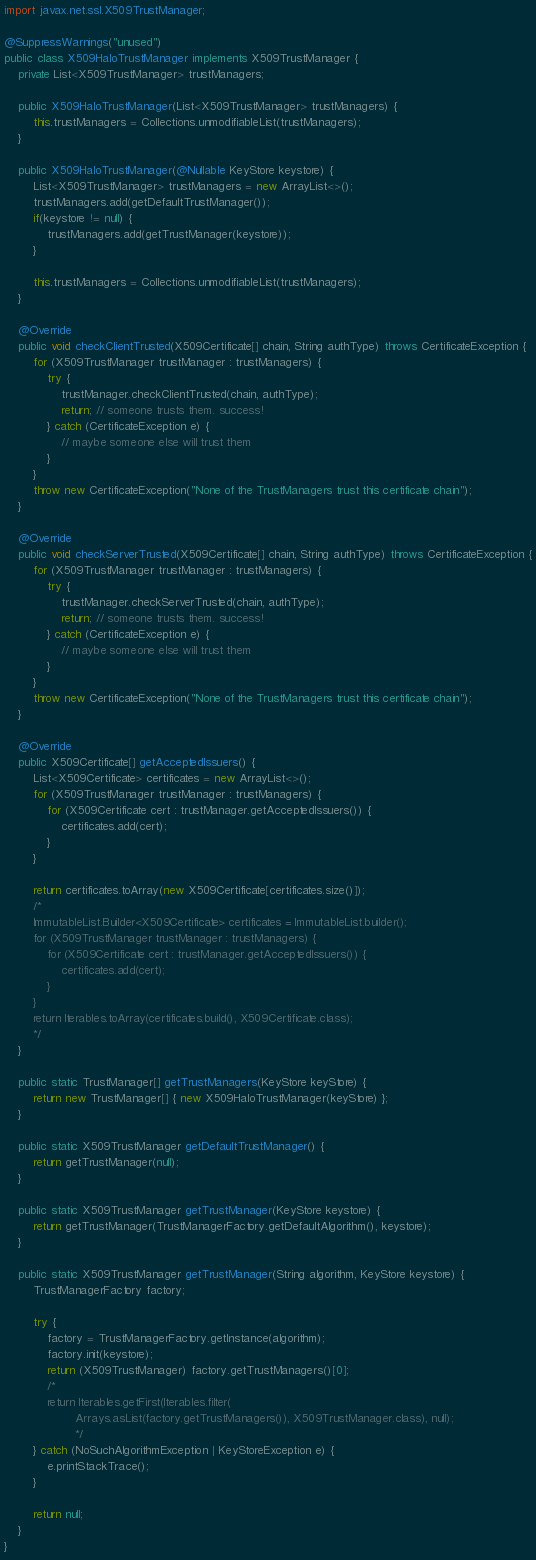Convert code to text. <code><loc_0><loc_0><loc_500><loc_500><_Java_>import javax.net.ssl.X509TrustManager;

@SuppressWarnings("unused")
public class X509HaloTrustManager implements X509TrustManager {
    private List<X509TrustManager> trustManagers;

    public X509HaloTrustManager(List<X509TrustManager> trustManagers) {
        this.trustManagers = Collections.unmodifiableList(trustManagers);
    }

    public X509HaloTrustManager(@Nullable KeyStore keystore) {
        List<X509TrustManager> trustManagers = new ArrayList<>();
        trustManagers.add(getDefaultTrustManager());
        if(keystore != null) {
            trustManagers.add(getTrustManager(keystore));
        }

        this.trustManagers = Collections.unmodifiableList(trustManagers);
    }

    @Override
    public void checkClientTrusted(X509Certificate[] chain, String authType) throws CertificateException {
        for (X509TrustManager trustManager : trustManagers) {
            try {
                trustManager.checkClientTrusted(chain, authType);
                return; // someone trusts them. success!
            } catch (CertificateException e) {
                // maybe someone else will trust them
            }
        }
        throw new CertificateException("None of the TrustManagers trust this certificate chain");
    }

    @Override
    public void checkServerTrusted(X509Certificate[] chain, String authType) throws CertificateException {
        for (X509TrustManager trustManager : trustManagers) {
            try {
                trustManager.checkServerTrusted(chain, authType);
                return; // someone trusts them. success!
            } catch (CertificateException e) {
                // maybe someone else will trust them
            }
        }
        throw new CertificateException("None of the TrustManagers trust this certificate chain");
    }

    @Override
    public X509Certificate[] getAcceptedIssuers() {
        List<X509Certificate> certificates = new ArrayList<>();
        for (X509TrustManager trustManager : trustManagers) {
            for (X509Certificate cert : trustManager.getAcceptedIssuers()) {
                certificates.add(cert);
            }
        }

        return certificates.toArray(new X509Certificate[certificates.size()]);
        /*
        ImmutableList.Builder<X509Certificate> certificates = ImmutableList.builder();
        for (X509TrustManager trustManager : trustManagers) {
            for (X509Certificate cert : trustManager.getAcceptedIssuers()) {
                certificates.add(cert);
            }
        }
        return Iterables.toArray(certificates.build(), X509Certificate.class);
        */
    }

    public static TrustManager[] getTrustManagers(KeyStore keyStore) {
        return new TrustManager[] { new X509HaloTrustManager(keyStore) };
    }

    public static X509TrustManager getDefaultTrustManager() {
        return getTrustManager(null);
    }

    public static X509TrustManager getTrustManager(KeyStore keystore) {
        return getTrustManager(TrustManagerFactory.getDefaultAlgorithm(), keystore);
    }

    public static X509TrustManager getTrustManager(String algorithm, KeyStore keystore) {
        TrustManagerFactory factory;

        try {
            factory = TrustManagerFactory.getInstance(algorithm);
            factory.init(keystore);
            return (X509TrustManager) factory.getTrustManagers()[0];
            /*
            return Iterables.getFirst(Iterables.filter(
                    Arrays.asList(factory.getTrustManagers()), X509TrustManager.class), null);
                    */
        } catch (NoSuchAlgorithmException | KeyStoreException e) {
            e.printStackTrace();
        }

        return null;
    }
}</code> 